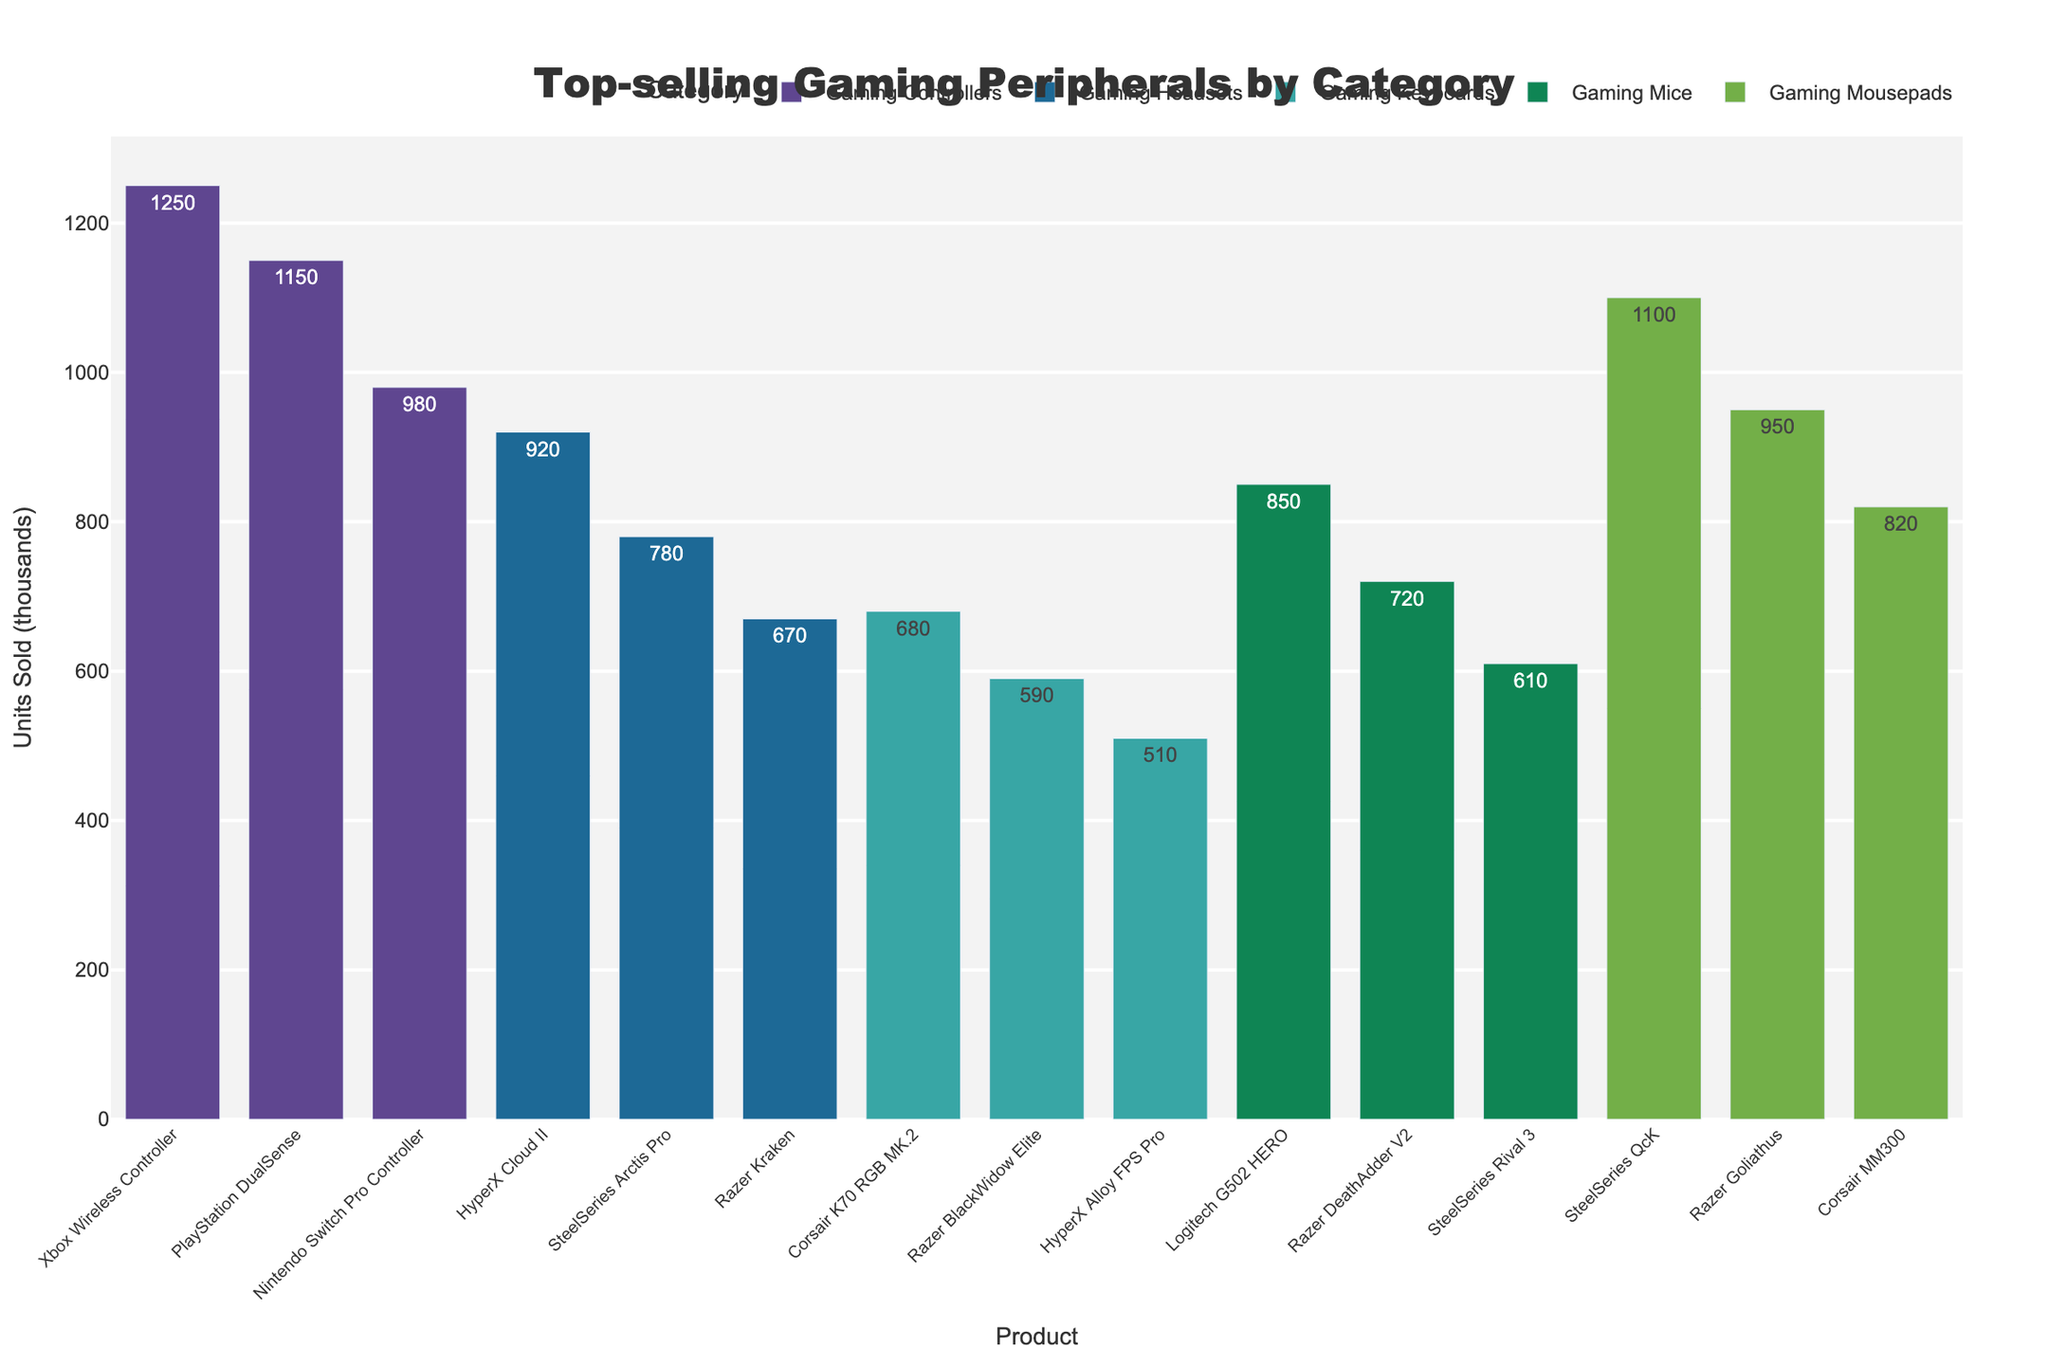Which product has the highest number of units sold in the "Gaming Controllers" category? First, identify the "Gaming Controllers" category. Then, pick the product with the highest bar height among "Xbox Wireless Controller", "PlayStation DualSense", and "Nintendo Switch Pro Controller". The "Xbox Wireless Controller" bar is the tallest in this category.
Answer: Xbox Wireless Controller Which product category sold the most units in total? Sum the units sold for each product in each category. The category with the highest sum is the one with the tallest stacked bars. Add up the units for "Gaming Controllers" (1250 + 1150 + 980 = 3380), "Gaming Mice" (850 + 720 + 610 = 2180), "Gaming Keyboards" (680 + 590 + 510 = 1780), "Gaming Headsets" (920 + 780 + 670 = 2370), "Gaming Mousepads" (1100 + 950 + 820 = 2870). "Gaming Controllers" has the highest sum.
Answer: Gaming Controllers How many more units did the "Xbox Wireless Controller" sell compared to the "Logitech G502 HERO"? Identify the units sold in the "Gaming Controllers" category for "Xbox Wireless Controller" (1250k) and in the "Gaming Mice" category for "Logitech G502 HERO" (850k). Subtract the latter from the former: 1250k - 850k = 400k.
Answer: 400k What is the average units sold for the products in the "Gaming Headsets" category? Identify the units sold for "HyperX Cloud II" (920k), "SteelSeries Arctis Pro" (780k), and "Razer Kraken" (670k). Compute their sum: 920k + 780k + 670k = 2370k. Divide the sum by the number of products: 2370k / 3 = 790k.
Answer: 790k Which product in the "Gaming Keyboards" category sold the least? Examine the "Gaming Keyboards" category and compare the heights of the bars for "Corsair K70 RGB MK.2", "Razer BlackWidow Elite", and "HyperX Alloy FPS Pro". The "HyperX Alloy FPS Pro" has the shortest bar.
Answer: HyperX Alloy FPS Pro Which has the higher total unit sales: "Gaming Mice" or "Gaming Mousepads"? Add up the units sold for each product in the "Gaming Mice" (850k + 720k + 610k = 2180k) and "Gaming Mousepads" (1100k + 950k + 820k = 2870k). Compare the totals. "Gaming Mousepads" has a higher total.
Answer: Gaming Mousepads If you combine the total units sold for "Razer" branded products, what is the sum? Identify and sum the units sold for all "Razer" products: "Razer DeathAdder V2" (720k), "Razer BlackWidow Elite" (590k), "Razer Kraken" (670k), and "Razer Goliathus" (950k). Sum: 720k + 590k + 670k + 950k = 2930k.
Answer: 2930k Which category has the smallest range (difference between the highest and lowest units sold)? Calculate the range for each category: "Gaming Mice" (850k - 610k = 240k), "Gaming Keyboards" (680k - 510k = 170k), "Gaming Headsets" (920k - 670k = 250k), "Gaming Mousepads" (1100k - 820k = 280k), and "Gaming Controllers" (1250k - 980k = 270k). The "Gaming Keyboards" category has the smallest range.
Answer: Gaming Keyboards For which product were the units sold closest to 1000k? Compare the units sold for each product to 1000k to find the closest. Products and deviations are: "Xbox Wireless Controller" (1250k - 1000k = 250k), "PlayStation DualSense" (1150k - 1000k = 150k), "Nintendo Switch Pro Controller" (980k - 1000k = 20k), and others with larger deviations. The "Nintendo Switch Pro Controller" is closest to 1000k with a deviation of 20k.
Answer: Nintendo Switch Pro Controller 